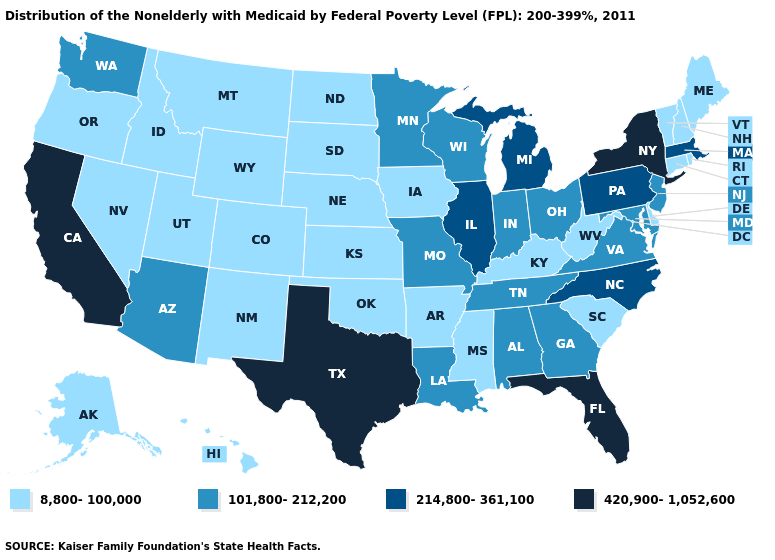Name the states that have a value in the range 214,800-361,100?
Keep it brief. Illinois, Massachusetts, Michigan, North Carolina, Pennsylvania. What is the lowest value in the USA?
Short answer required. 8,800-100,000. What is the value of Maine?
Concise answer only. 8,800-100,000. What is the lowest value in the USA?
Be succinct. 8,800-100,000. What is the lowest value in states that border Massachusetts?
Keep it brief. 8,800-100,000. How many symbols are there in the legend?
Short answer required. 4. What is the value of Colorado?
Answer briefly. 8,800-100,000. Among the states that border Maryland , does Virginia have the highest value?
Give a very brief answer. No. What is the highest value in the West ?
Be succinct. 420,900-1,052,600. Does Ohio have the same value as Pennsylvania?
Give a very brief answer. No. What is the lowest value in the South?
Keep it brief. 8,800-100,000. Among the states that border Montana , which have the highest value?
Short answer required. Idaho, North Dakota, South Dakota, Wyoming. Name the states that have a value in the range 101,800-212,200?
Be succinct. Alabama, Arizona, Georgia, Indiana, Louisiana, Maryland, Minnesota, Missouri, New Jersey, Ohio, Tennessee, Virginia, Washington, Wisconsin. Name the states that have a value in the range 101,800-212,200?
Be succinct. Alabama, Arizona, Georgia, Indiana, Louisiana, Maryland, Minnesota, Missouri, New Jersey, Ohio, Tennessee, Virginia, Washington, Wisconsin. Name the states that have a value in the range 420,900-1,052,600?
Answer briefly. California, Florida, New York, Texas. 